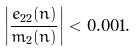Convert formula to latex. <formula><loc_0><loc_0><loc_500><loc_500>\left | \frac { e _ { 2 2 } ( n ) } { m _ { 2 } ( n ) } \right | < 0 . 0 0 1 .</formula> 